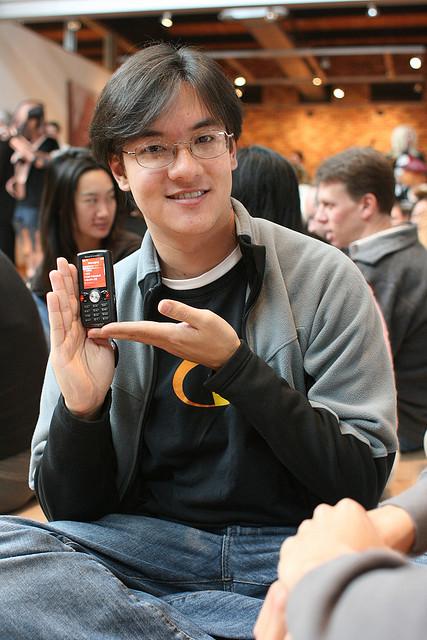How is this person's eyesight?
Be succinct. Bad. Could the man be traveling?
Give a very brief answer. No. What is he showing off?
Be succinct. Cell phone. Is the man wearing sunglasses?
Concise answer only. No. Is the guy proud of his mobile phone?
Concise answer only. Yes. 